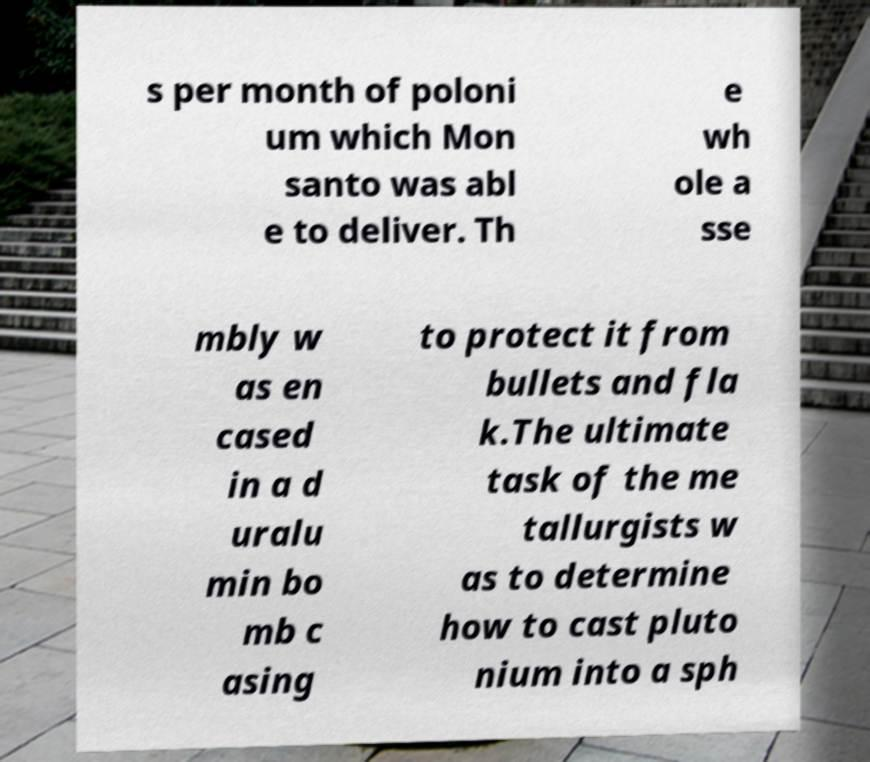Can you read and provide the text displayed in the image?This photo seems to have some interesting text. Can you extract and type it out for me? s per month of poloni um which Mon santo was abl e to deliver. Th e wh ole a sse mbly w as en cased in a d uralu min bo mb c asing to protect it from bullets and fla k.The ultimate task of the me tallurgists w as to determine how to cast pluto nium into a sph 